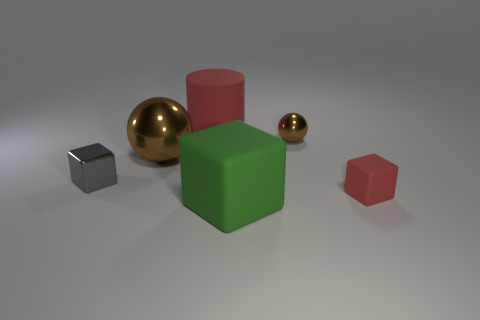Add 2 green things. How many objects exist? 8 Subtract all cylinders. How many objects are left? 5 Subtract 1 gray cubes. How many objects are left? 5 Subtract all purple rubber balls. Subtract all metal cubes. How many objects are left? 5 Add 6 tiny things. How many tiny things are left? 9 Add 2 brown shiny balls. How many brown shiny balls exist? 4 